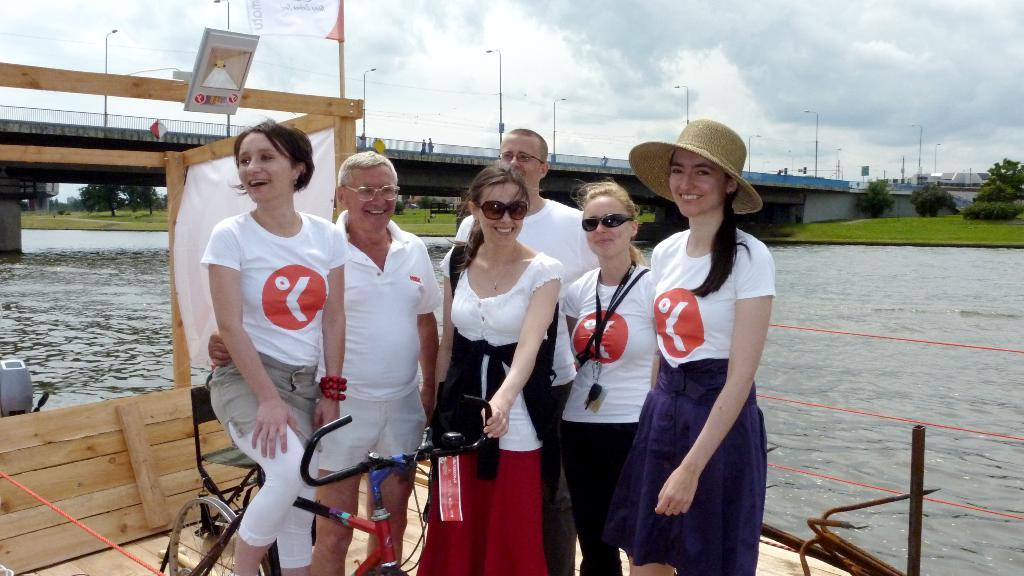What can be seen in the sky in the image? The information provided does not specify any details about the sky in the image. What type of structure is present in the image? There is a bridge in the image. What is visible in the water in the image? The information provided does not specify any details about the water in the image. What type of vegetation is present in the image? There are trees in the image. What are the people in the image doing? The information provided does not specify any details about the people in the image. How many rabbits can be seen hopping on the side of the bridge in the image? There are no rabbits present in the image. Can you provide an example of a person's clothing in the image? The information provided does not specify any details about the people's clothing in the image. 